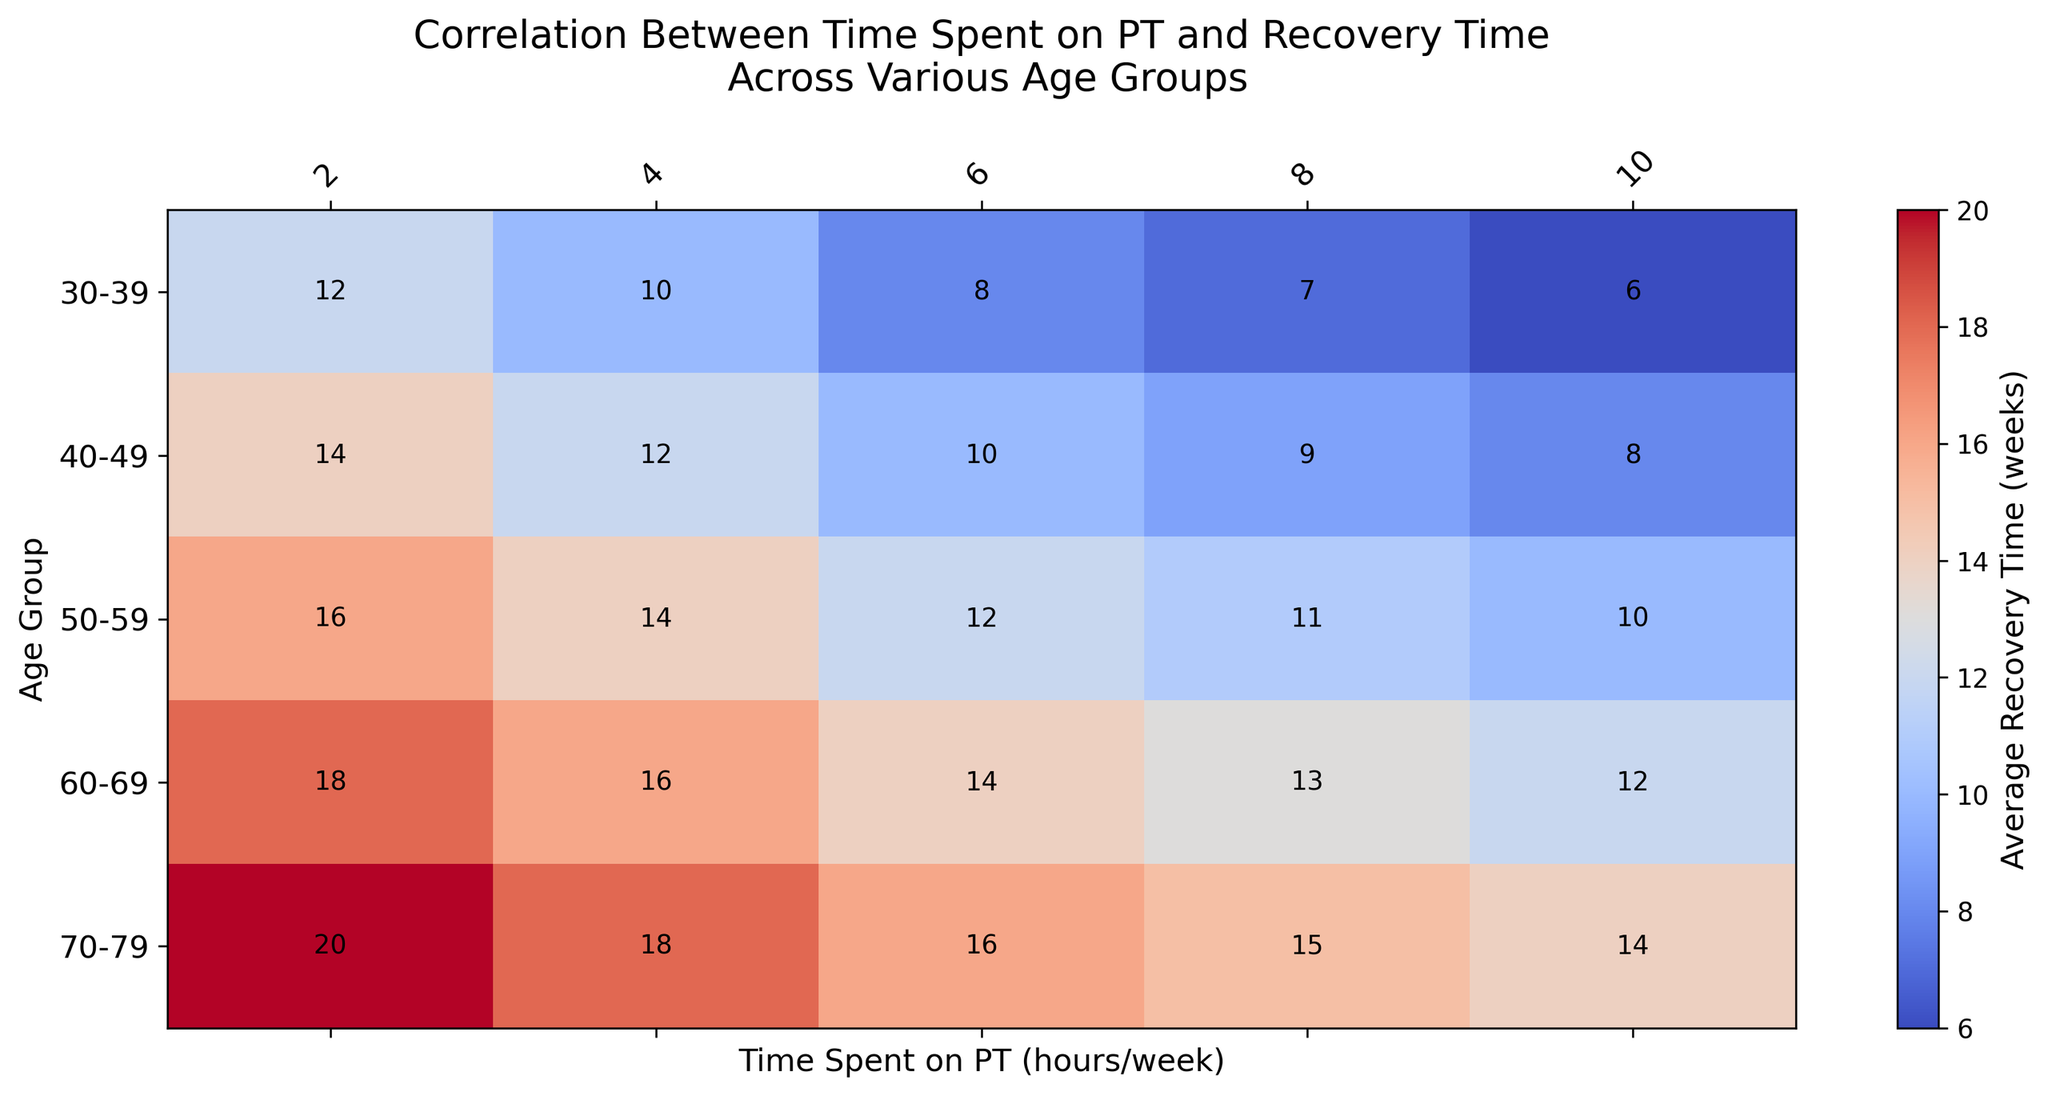What is the average recovery time for the 60-69 age group when they spend 6 hours per week on PT? To find the average recovery time for the 60-69 age group when they spend 6 hours per week on PT, locate the cell where the '60-69' row intersects with the '6 hours/week' column.
Answer: 14 weeks Which age group has the shortest average recovery time when spending 10 hours per week on PT? To determine which age group has the shortest recovery time for 10 hours/week of PT, identify the value in each row under the '10 hours/week' column and find the smallest number.
Answer: 30-39 age group (6 weeks) Compare the average recovery times between the 40-49 and 50-59 age groups when spending 4 hours per week on PT. Which age group recovers faster? Locate the cells for the '40-49' and '50-59' age groups under the '4 hours/week' column and compare the values. 14 weeks (50-59) is greater than 12 weeks (40-49), so the 40-49 group recovers faster.
Answer: 40-49 age group What is the sum of the average recovery times for the 70-79 age group across all levels of PT? Add all the recovery times for the 70-79 age group across different PT hours (2, 4, 6, 8, 10 hours per week): 20 + 18 + 16 + 15 + 14. The sum is 83 weeks.
Answer: 83 weeks How does the average recovery time change for the 30-39 age group as the time spent on PT increases from 2 hours to 10 hours per week? Observe the trend in recovery times for the 30-39 age group across increasing PT hours: It consistently decreases from 12 to 6 weeks as PT hours increase from 2 to 10 hours.
Answer: Decreases Which PT duration (in hours per week) results in the longest recovery time for the 60-69 age group? To find the PT duration that leads to the longest recovery for the 60-69 age group, look at each PT column for the 60-69 age group. The maximum value is 18 weeks for 2 hours/week.
Answer: 2 hours per week Is there a consistent trend in recovery times as PT hours increase across the 70-79 age group? Examine the recovery times for the 70-79 age group as PT hours increase from 2 to 10 per week. The recovery time decreases from 20 to 14 weeks, indicating a consistent downward trend.
Answer: Yes Compare the colors representing the highest and lowest recovery times in the heatmap. What colors do they correspond to? The highest recovery times (20 weeks) appear in darker shades, whereas the lowest recovery times (6 weeks) are in lighter shades, indicating a gradient from dark (long recovery) to light (short recovery).
Answer: Dark shade and light shade What is the difference between the average recovery times of the 50-59 and 60-69 age groups when both spend 8 hours per week on PT? Identify the recovery times for the '50-59' and '60-69' age groups under the '8 hours/week' column. Subtract the recovery time of 60-69 (13 weeks) from 50-59 (11 weeks): 13 - 11 = 2 weeks.
Answer: 2 weeks 